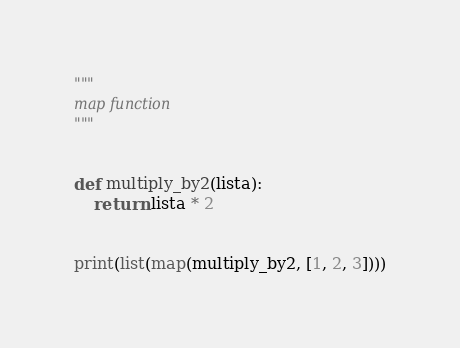<code> <loc_0><loc_0><loc_500><loc_500><_Python_>"""
map function
"""


def multiply_by2(lista):
    return lista * 2


print(list(map(multiply_by2, [1, 2, 3])))
</code> 